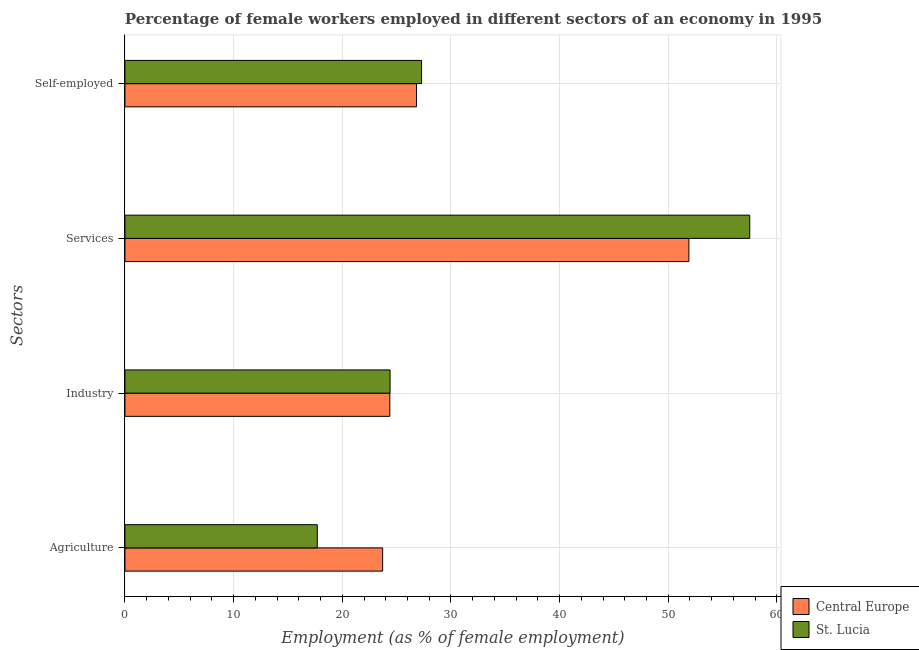Are the number of bars per tick equal to the number of legend labels?
Provide a short and direct response. Yes. Are the number of bars on each tick of the Y-axis equal?
Give a very brief answer. Yes. How many bars are there on the 1st tick from the top?
Provide a succinct answer. 2. What is the label of the 4th group of bars from the top?
Provide a succinct answer. Agriculture. What is the percentage of self employed female workers in Central Europe?
Your response must be concise. 26.83. Across all countries, what is the maximum percentage of female workers in services?
Keep it short and to the point. 57.5. Across all countries, what is the minimum percentage of female workers in services?
Offer a terse response. 51.9. In which country was the percentage of female workers in services maximum?
Give a very brief answer. St. Lucia. In which country was the percentage of female workers in agriculture minimum?
Your answer should be very brief. St. Lucia. What is the total percentage of female workers in services in the graph?
Offer a very short reply. 109.4. What is the difference between the percentage of female workers in services in St. Lucia and that in Central Europe?
Provide a short and direct response. 5.6. What is the difference between the percentage of female workers in industry in St. Lucia and the percentage of female workers in agriculture in Central Europe?
Provide a short and direct response. 0.68. What is the average percentage of self employed female workers per country?
Offer a very short reply. 27.07. What is the difference between the percentage of female workers in services and percentage of female workers in industry in Central Europe?
Ensure brevity in your answer.  27.52. What is the ratio of the percentage of self employed female workers in St. Lucia to that in Central Europe?
Your answer should be compact. 1.02. Is the percentage of female workers in industry in St. Lucia less than that in Central Europe?
Make the answer very short. No. What is the difference between the highest and the second highest percentage of self employed female workers?
Make the answer very short. 0.47. What is the difference between the highest and the lowest percentage of self employed female workers?
Your answer should be very brief. 0.47. In how many countries, is the percentage of female workers in agriculture greater than the average percentage of female workers in agriculture taken over all countries?
Give a very brief answer. 1. Is it the case that in every country, the sum of the percentage of female workers in industry and percentage of female workers in services is greater than the sum of percentage of female workers in agriculture and percentage of self employed female workers?
Provide a succinct answer. Yes. What does the 1st bar from the top in Self-employed represents?
Provide a short and direct response. St. Lucia. What does the 2nd bar from the bottom in Agriculture represents?
Provide a short and direct response. St. Lucia. How many countries are there in the graph?
Your answer should be compact. 2. What is the difference between two consecutive major ticks on the X-axis?
Your answer should be very brief. 10. Are the values on the major ticks of X-axis written in scientific E-notation?
Your answer should be very brief. No. Does the graph contain any zero values?
Your answer should be compact. No. Does the graph contain grids?
Your answer should be compact. Yes. Where does the legend appear in the graph?
Make the answer very short. Bottom right. How are the legend labels stacked?
Offer a terse response. Vertical. What is the title of the graph?
Your answer should be compact. Percentage of female workers employed in different sectors of an economy in 1995. What is the label or title of the X-axis?
Your answer should be very brief. Employment (as % of female employment). What is the label or title of the Y-axis?
Offer a very short reply. Sectors. What is the Employment (as % of female employment) in Central Europe in Agriculture?
Keep it short and to the point. 23.72. What is the Employment (as % of female employment) in St. Lucia in Agriculture?
Provide a succinct answer. 17.7. What is the Employment (as % of female employment) in Central Europe in Industry?
Provide a succinct answer. 24.38. What is the Employment (as % of female employment) in St. Lucia in Industry?
Make the answer very short. 24.4. What is the Employment (as % of female employment) of Central Europe in Services?
Keep it short and to the point. 51.9. What is the Employment (as % of female employment) of St. Lucia in Services?
Offer a terse response. 57.5. What is the Employment (as % of female employment) of Central Europe in Self-employed?
Give a very brief answer. 26.83. What is the Employment (as % of female employment) in St. Lucia in Self-employed?
Your response must be concise. 27.3. Across all Sectors, what is the maximum Employment (as % of female employment) of Central Europe?
Provide a succinct answer. 51.9. Across all Sectors, what is the maximum Employment (as % of female employment) in St. Lucia?
Offer a very short reply. 57.5. Across all Sectors, what is the minimum Employment (as % of female employment) of Central Europe?
Your answer should be very brief. 23.72. Across all Sectors, what is the minimum Employment (as % of female employment) in St. Lucia?
Keep it short and to the point. 17.7. What is the total Employment (as % of female employment) in Central Europe in the graph?
Provide a short and direct response. 126.82. What is the total Employment (as % of female employment) of St. Lucia in the graph?
Give a very brief answer. 126.9. What is the difference between the Employment (as % of female employment) of Central Europe in Agriculture and that in Industry?
Give a very brief answer. -0.66. What is the difference between the Employment (as % of female employment) in St. Lucia in Agriculture and that in Industry?
Provide a short and direct response. -6.7. What is the difference between the Employment (as % of female employment) in Central Europe in Agriculture and that in Services?
Provide a short and direct response. -28.18. What is the difference between the Employment (as % of female employment) in St. Lucia in Agriculture and that in Services?
Your response must be concise. -39.8. What is the difference between the Employment (as % of female employment) in Central Europe in Agriculture and that in Self-employed?
Offer a terse response. -3.12. What is the difference between the Employment (as % of female employment) of St. Lucia in Agriculture and that in Self-employed?
Your answer should be very brief. -9.6. What is the difference between the Employment (as % of female employment) of Central Europe in Industry and that in Services?
Your answer should be very brief. -27.52. What is the difference between the Employment (as % of female employment) of St. Lucia in Industry and that in Services?
Keep it short and to the point. -33.1. What is the difference between the Employment (as % of female employment) of Central Europe in Industry and that in Self-employed?
Provide a short and direct response. -2.46. What is the difference between the Employment (as % of female employment) in Central Europe in Services and that in Self-employed?
Offer a terse response. 25.07. What is the difference between the Employment (as % of female employment) of St. Lucia in Services and that in Self-employed?
Give a very brief answer. 30.2. What is the difference between the Employment (as % of female employment) of Central Europe in Agriculture and the Employment (as % of female employment) of St. Lucia in Industry?
Ensure brevity in your answer.  -0.68. What is the difference between the Employment (as % of female employment) of Central Europe in Agriculture and the Employment (as % of female employment) of St. Lucia in Services?
Provide a succinct answer. -33.78. What is the difference between the Employment (as % of female employment) of Central Europe in Agriculture and the Employment (as % of female employment) of St. Lucia in Self-employed?
Your answer should be compact. -3.58. What is the difference between the Employment (as % of female employment) in Central Europe in Industry and the Employment (as % of female employment) in St. Lucia in Services?
Offer a terse response. -33.12. What is the difference between the Employment (as % of female employment) of Central Europe in Industry and the Employment (as % of female employment) of St. Lucia in Self-employed?
Offer a very short reply. -2.92. What is the difference between the Employment (as % of female employment) of Central Europe in Services and the Employment (as % of female employment) of St. Lucia in Self-employed?
Offer a terse response. 24.6. What is the average Employment (as % of female employment) in Central Europe per Sectors?
Offer a terse response. 31.71. What is the average Employment (as % of female employment) in St. Lucia per Sectors?
Give a very brief answer. 31.73. What is the difference between the Employment (as % of female employment) of Central Europe and Employment (as % of female employment) of St. Lucia in Agriculture?
Offer a very short reply. 6.02. What is the difference between the Employment (as % of female employment) of Central Europe and Employment (as % of female employment) of St. Lucia in Industry?
Your answer should be compact. -0.02. What is the difference between the Employment (as % of female employment) in Central Europe and Employment (as % of female employment) in St. Lucia in Services?
Ensure brevity in your answer.  -5.6. What is the difference between the Employment (as % of female employment) of Central Europe and Employment (as % of female employment) of St. Lucia in Self-employed?
Ensure brevity in your answer.  -0.47. What is the ratio of the Employment (as % of female employment) of Central Europe in Agriculture to that in Industry?
Provide a short and direct response. 0.97. What is the ratio of the Employment (as % of female employment) in St. Lucia in Agriculture to that in Industry?
Provide a short and direct response. 0.73. What is the ratio of the Employment (as % of female employment) of Central Europe in Agriculture to that in Services?
Give a very brief answer. 0.46. What is the ratio of the Employment (as % of female employment) in St. Lucia in Agriculture to that in Services?
Your response must be concise. 0.31. What is the ratio of the Employment (as % of female employment) of Central Europe in Agriculture to that in Self-employed?
Ensure brevity in your answer.  0.88. What is the ratio of the Employment (as % of female employment) in St. Lucia in Agriculture to that in Self-employed?
Make the answer very short. 0.65. What is the ratio of the Employment (as % of female employment) in Central Europe in Industry to that in Services?
Make the answer very short. 0.47. What is the ratio of the Employment (as % of female employment) of St. Lucia in Industry to that in Services?
Your answer should be compact. 0.42. What is the ratio of the Employment (as % of female employment) of Central Europe in Industry to that in Self-employed?
Keep it short and to the point. 0.91. What is the ratio of the Employment (as % of female employment) of St. Lucia in Industry to that in Self-employed?
Offer a terse response. 0.89. What is the ratio of the Employment (as % of female employment) of Central Europe in Services to that in Self-employed?
Provide a succinct answer. 1.93. What is the ratio of the Employment (as % of female employment) of St. Lucia in Services to that in Self-employed?
Ensure brevity in your answer.  2.11. What is the difference between the highest and the second highest Employment (as % of female employment) in Central Europe?
Offer a terse response. 25.07. What is the difference between the highest and the second highest Employment (as % of female employment) in St. Lucia?
Provide a short and direct response. 30.2. What is the difference between the highest and the lowest Employment (as % of female employment) of Central Europe?
Keep it short and to the point. 28.18. What is the difference between the highest and the lowest Employment (as % of female employment) of St. Lucia?
Your answer should be compact. 39.8. 